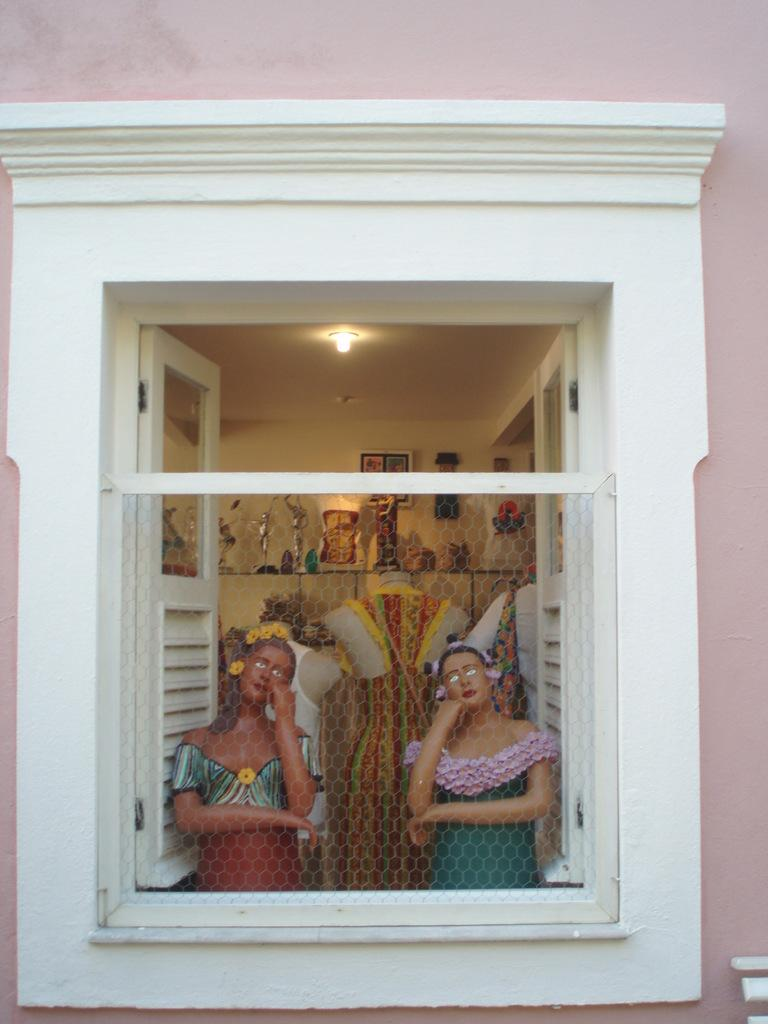What is the main subject of the image? The main subject of the image is a window of a house. What other items can be seen in the image? There are many toys and dolls in the image. Can you describe the light in the image? There is a light attached to a roof in the image. How many children are playing basketball in the image? There are no children or basketball present in the image. Is there a chicken visible in the image? There is no chicken present in the image. 